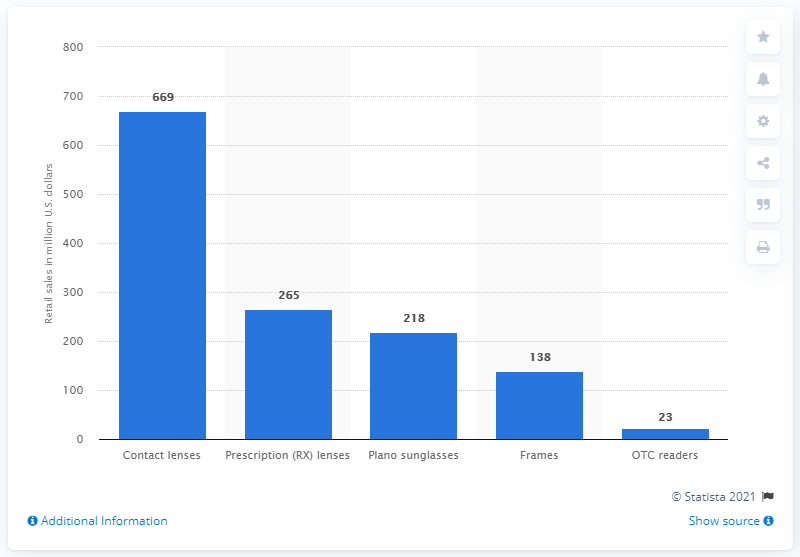List a handful of essential elements in this visual. The U.S. vision care market generated approximately $669 million from online contact lenses sales in 2015. 